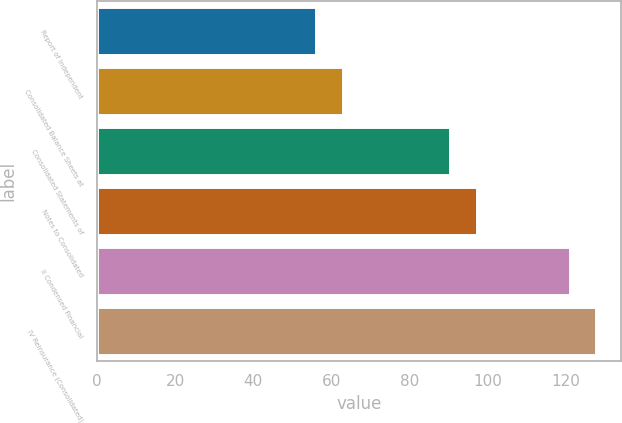<chart> <loc_0><loc_0><loc_500><loc_500><bar_chart><fcel>Report of Independent<fcel>Consolidated Balance Sheets at<fcel>Consolidated Statements of<fcel>Notes to Consolidated<fcel>II Condensed Financial<fcel>IV Reinsurance (Consolidated)<nl><fcel>56<fcel>62.9<fcel>90.5<fcel>97.4<fcel>121<fcel>127.9<nl></chart> 